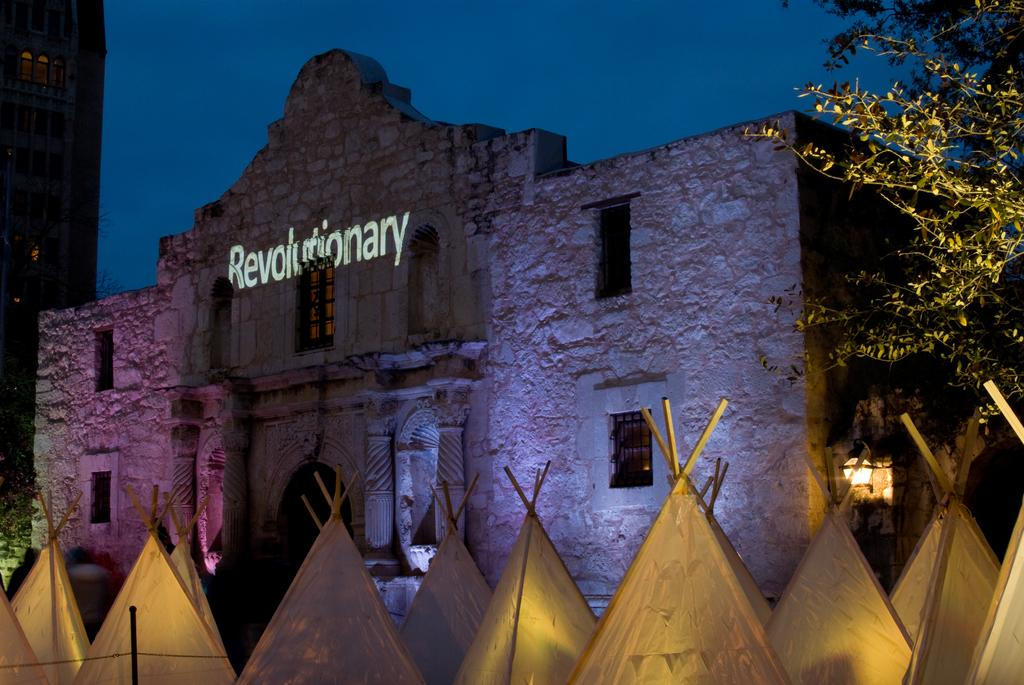<image>
Present a compact description of the photo's key features. A large brick building with the word Revolutionary being projected onto it and several tee-pees in front of it. 